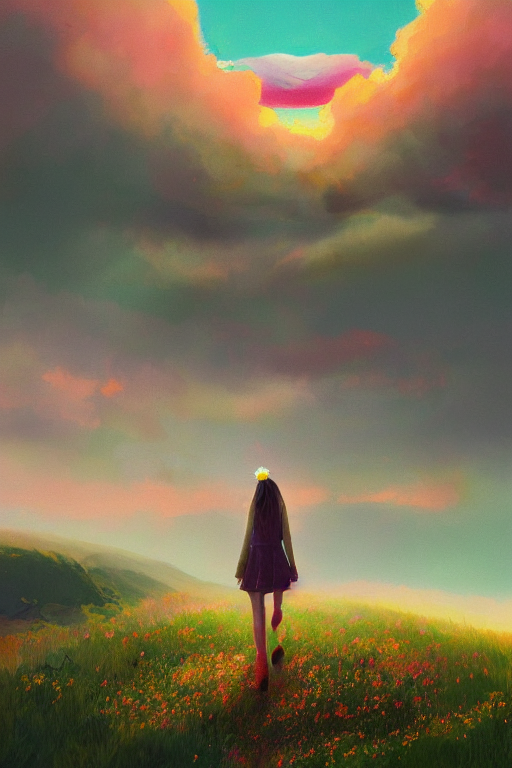Are the colors rich?
 Yes 